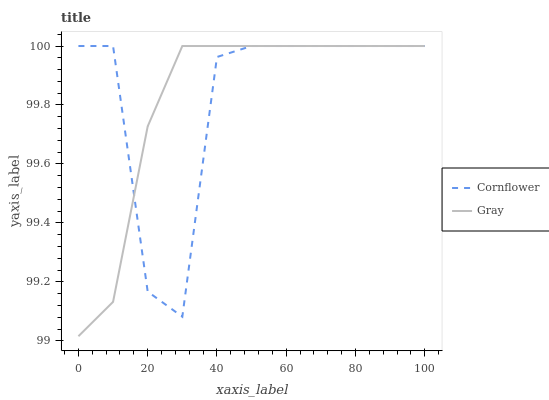Does Cornflower have the minimum area under the curve?
Answer yes or no. Yes. Does Gray have the maximum area under the curve?
Answer yes or no. Yes. Does Gray have the minimum area under the curve?
Answer yes or no. No. Is Gray the smoothest?
Answer yes or no. Yes. Is Cornflower the roughest?
Answer yes or no. Yes. Is Gray the roughest?
Answer yes or no. No. Does Gray have the lowest value?
Answer yes or no. Yes. Does Gray have the highest value?
Answer yes or no. Yes. Does Cornflower intersect Gray?
Answer yes or no. Yes. Is Cornflower less than Gray?
Answer yes or no. No. Is Cornflower greater than Gray?
Answer yes or no. No. 